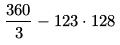<formula> <loc_0><loc_0><loc_500><loc_500>\frac { 3 6 0 } { 3 } - 1 2 3 \cdot 1 2 8</formula> 